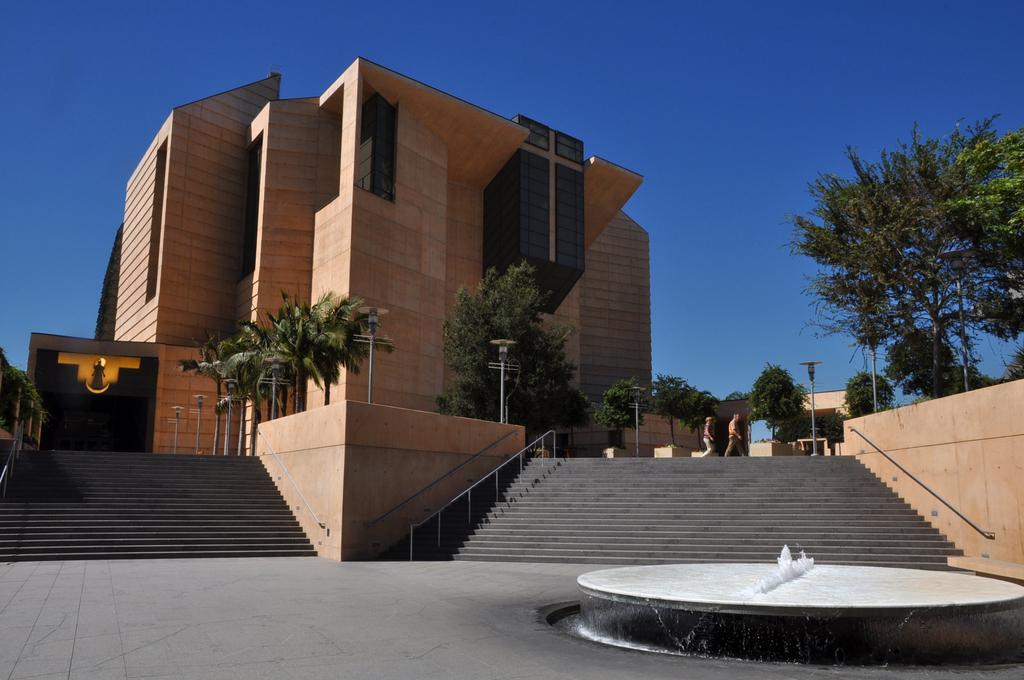How would you summarize this image in a sentence or two? In this image we can see a building. In front of the building there are trees, poles and steps with railings. On the right side there are trees. And there is a fountain. And there are two persons walking. In the background there is sky. 